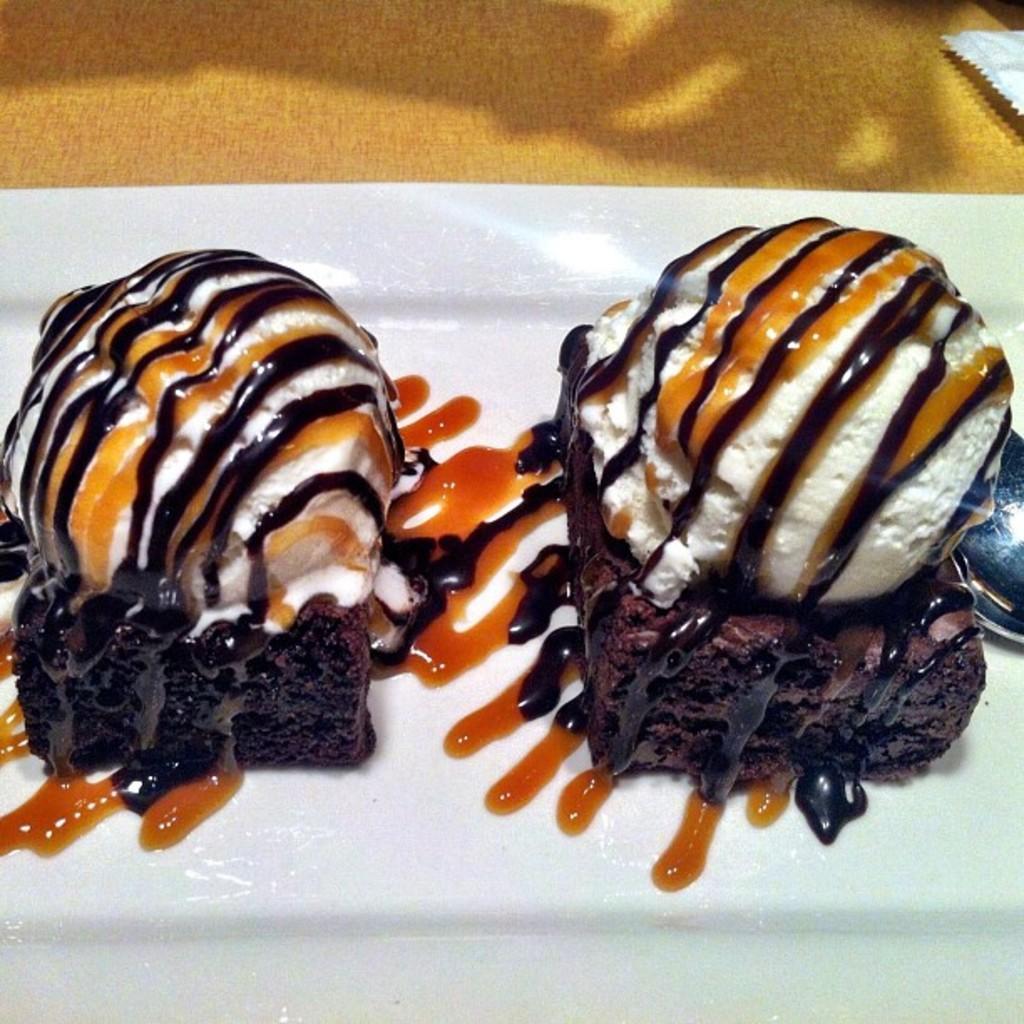How would you summarize this image in a sentence or two? In the image we can see a plate, on the plate we can see pieces of bread and on it we can see ice cream. Here we can see spoon and yellow surface. 